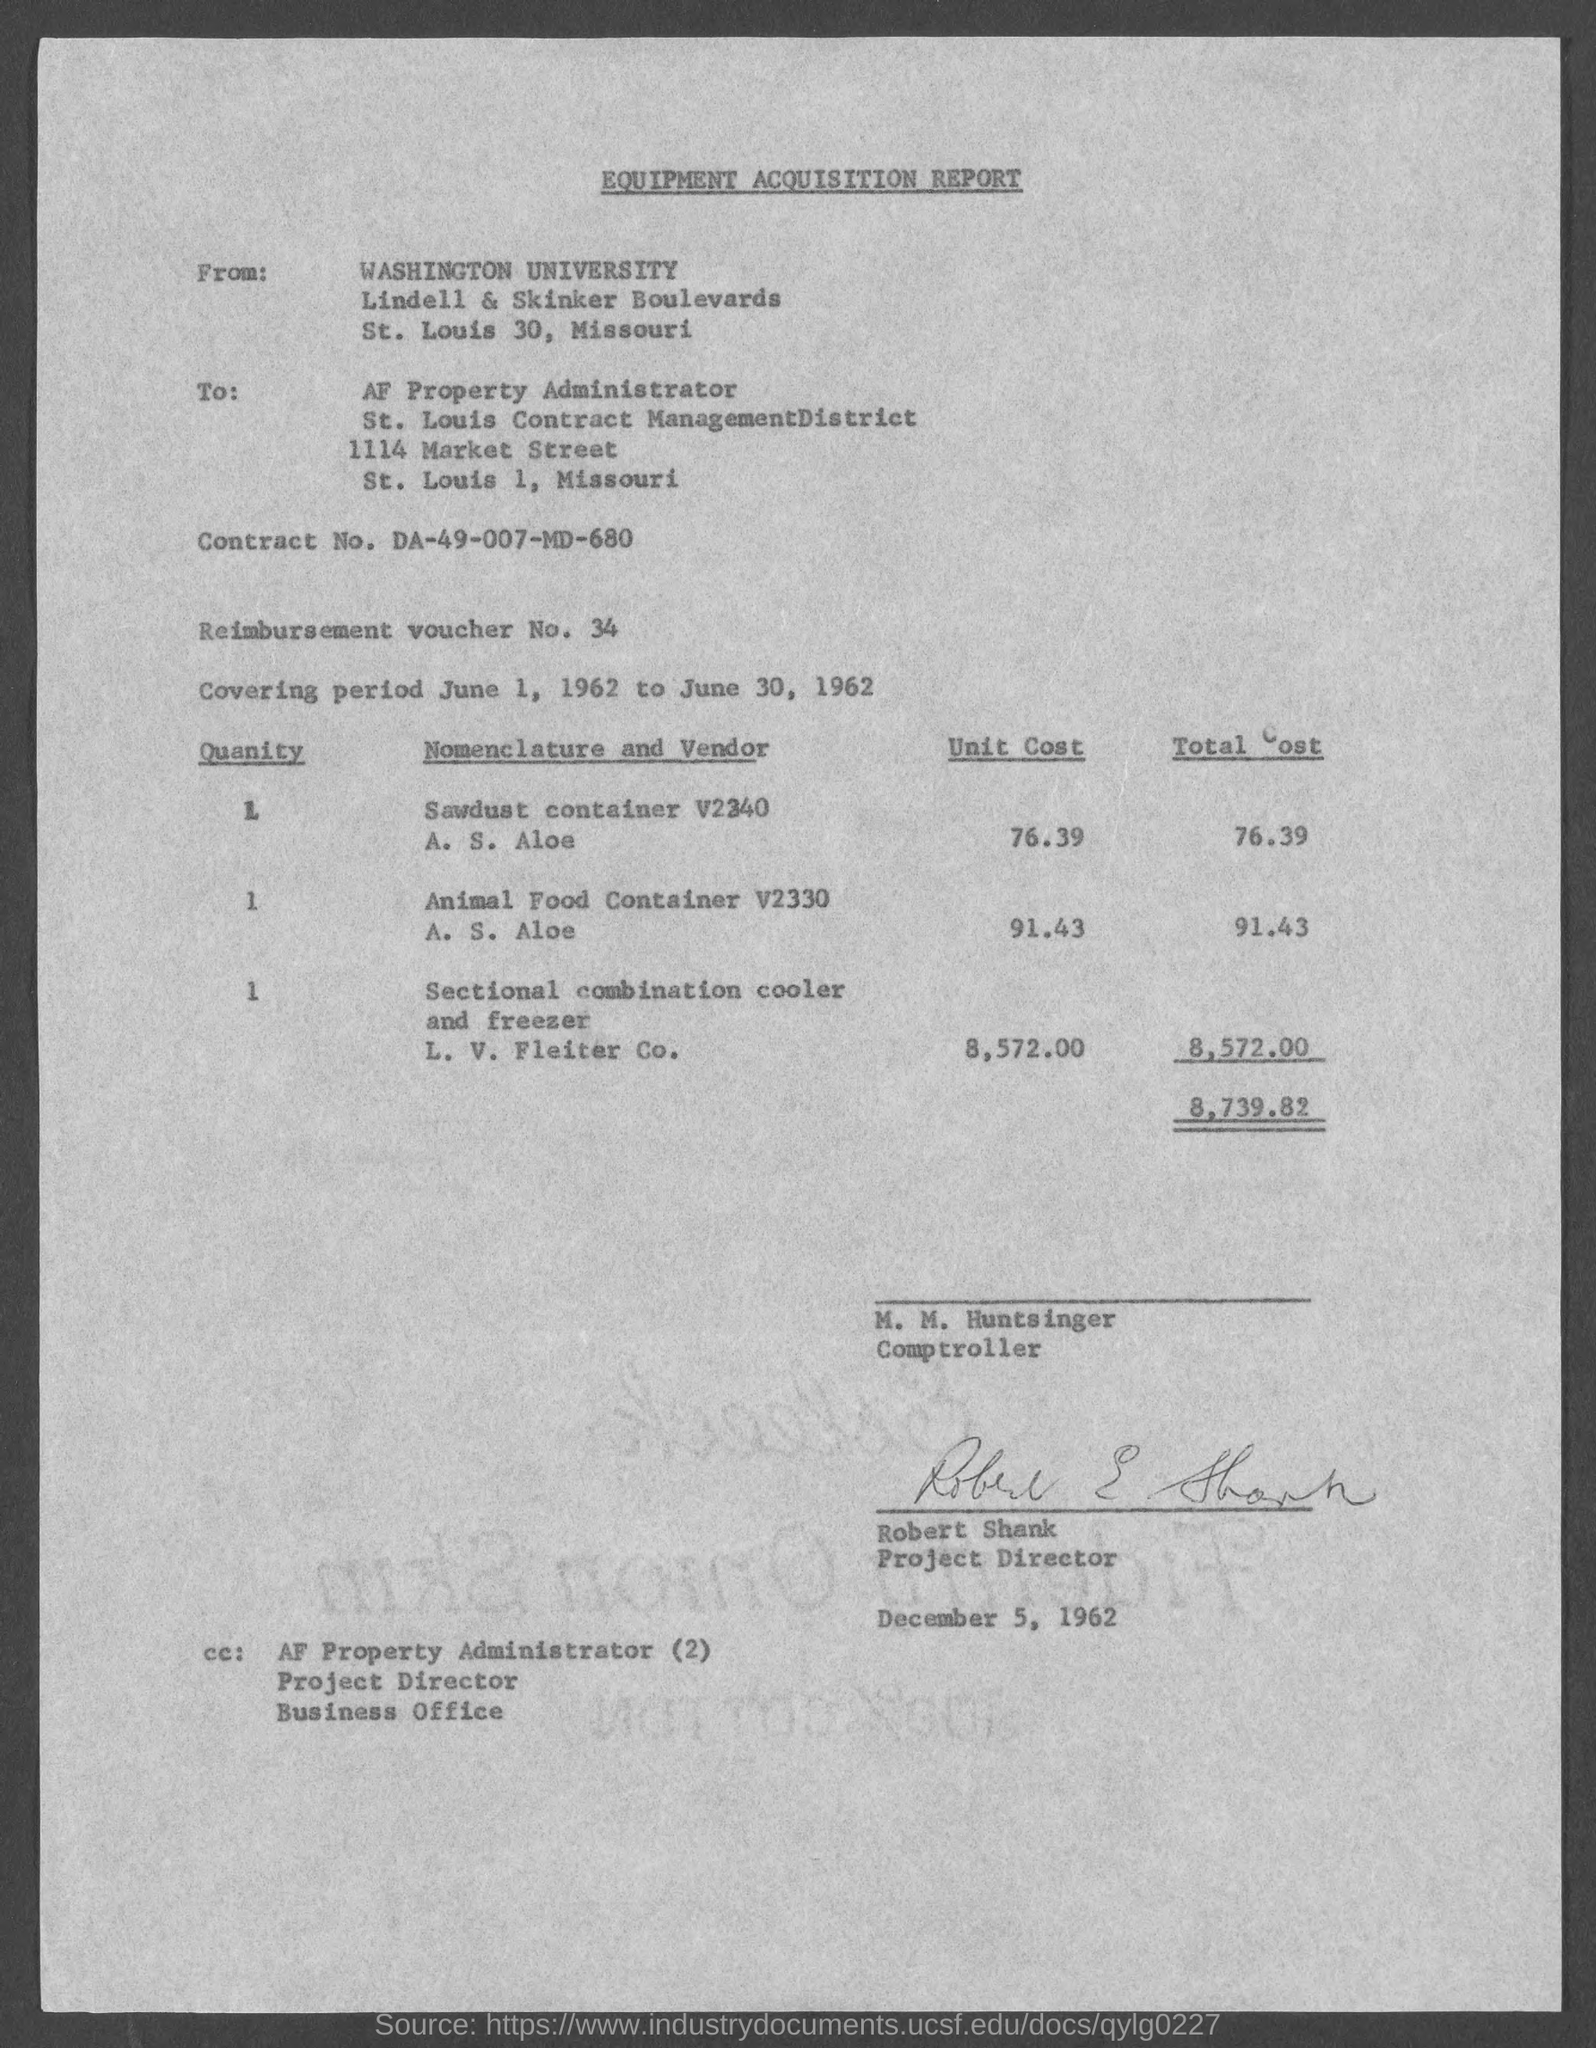Highlight a few significant elements in this photo. The title of the report is the Equipment Acquisition Report. The Project Director's name is Robert Shank. The report is addressed to the AF Property Administrator. What is Contract No. DA-49-007-MD-680?" is a question asking for information about a contract number. 